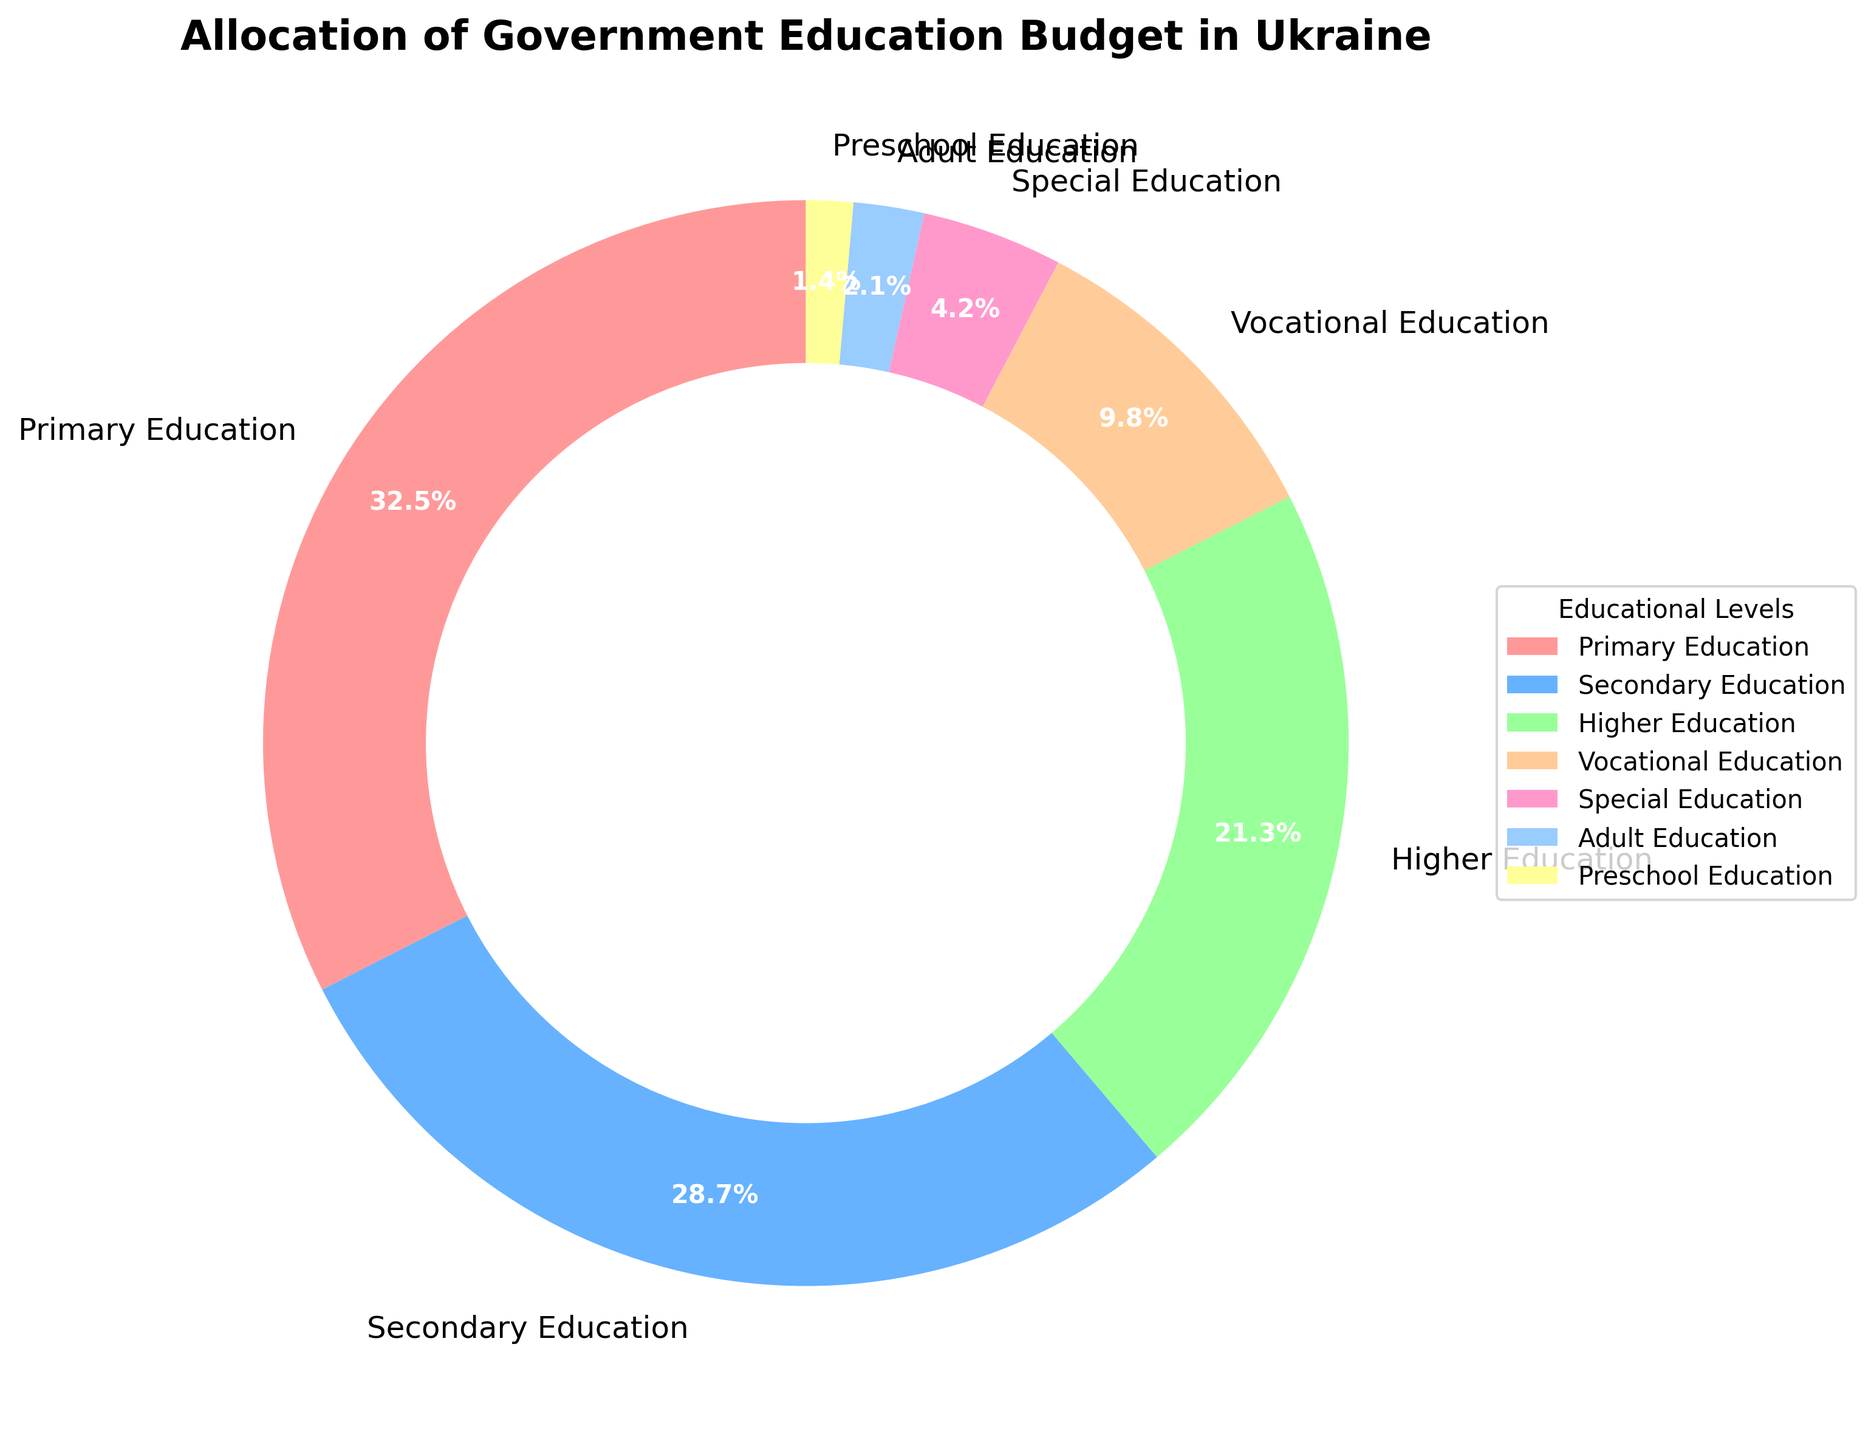Which educational level receives the highest budget allocation? The largest segment of the pie chart represents Primary Education, with a budget allocation percentage of 32.5%.
Answer: Primary Education How does the budget allocation for Secondary Education compare to that for Higher Education? Secondary Education has a budget allocation of 28.7%, whereas Higher Education has 21.3%. Since 28.7% is greater than 21.3%, Secondary Education receives more budget than Higher Education.
Answer: Secondary Education receives more budget than Higher Education What is the combined budget allocation percentage for Vocational and Special Education? The budget allocation for Vocational Education is 9.8% and for Special Education is 4.2%. Adding these two percentages: 9.8% + 4.2% = 14.0%.
Answer: 14.0% If the total budget is $1,000,000, how much money is allocated to Adult Education? The percentage of the budget allocated to Adult Education is 2.1%. Multiplying this percentage by the total budget: (2.1/100) * $1,000,000 = $21,000.
Answer: $21,000 What proportion of the budget is allocated to Preschool Education relative to Primary Education? Preschool Education receives 1.4% of the budget, while Primary Education receives 32.5%. To find the proportion: 1.4% / 32.5% = 0.043 (rounded to three decimal places).
Answer: 0.043 Which educational levels combined receive more than 50% of the budget? Primary Education (32.5%) and Secondary Education (28.7%) together make up 32.5% + 28.7% = 61.2%, which is more than 50%.
Answer: Primary and Secondary Education What is the color used to represent Vocational Education? The segment representing Vocational Education is colored in blue.
Answer: Blue What is the difference in percentage allocation between Secondary and Vocational Education? The allocation for Secondary Education is 28.7%, and for Vocational Education, it is 9.8%. The difference is 28.7% - 9.8% = 18.9%.
Answer: 18.9% What percentage of the budget is allocated to levels of education other than Primary and Secondary? First, we sum the budget percentages for Primary and Secondary Education, which is 32.5% + 28.7% = 61.2%. Then, we subtract this from 100% to find the allocation for other levels: 100% - 61.2% = 38.8%.
Answer: 38.8% How does the budget allocation for Adult Education compare to that for Preschool Education? Adult Education has a budget allocation of 2.1%, while Preschool Education has 1.4%. Since 2.1% is greater than 1.4%, Adult Education receives more budget than Preschool Education.
Answer: Adult Education receives more budget than Preschool Education 